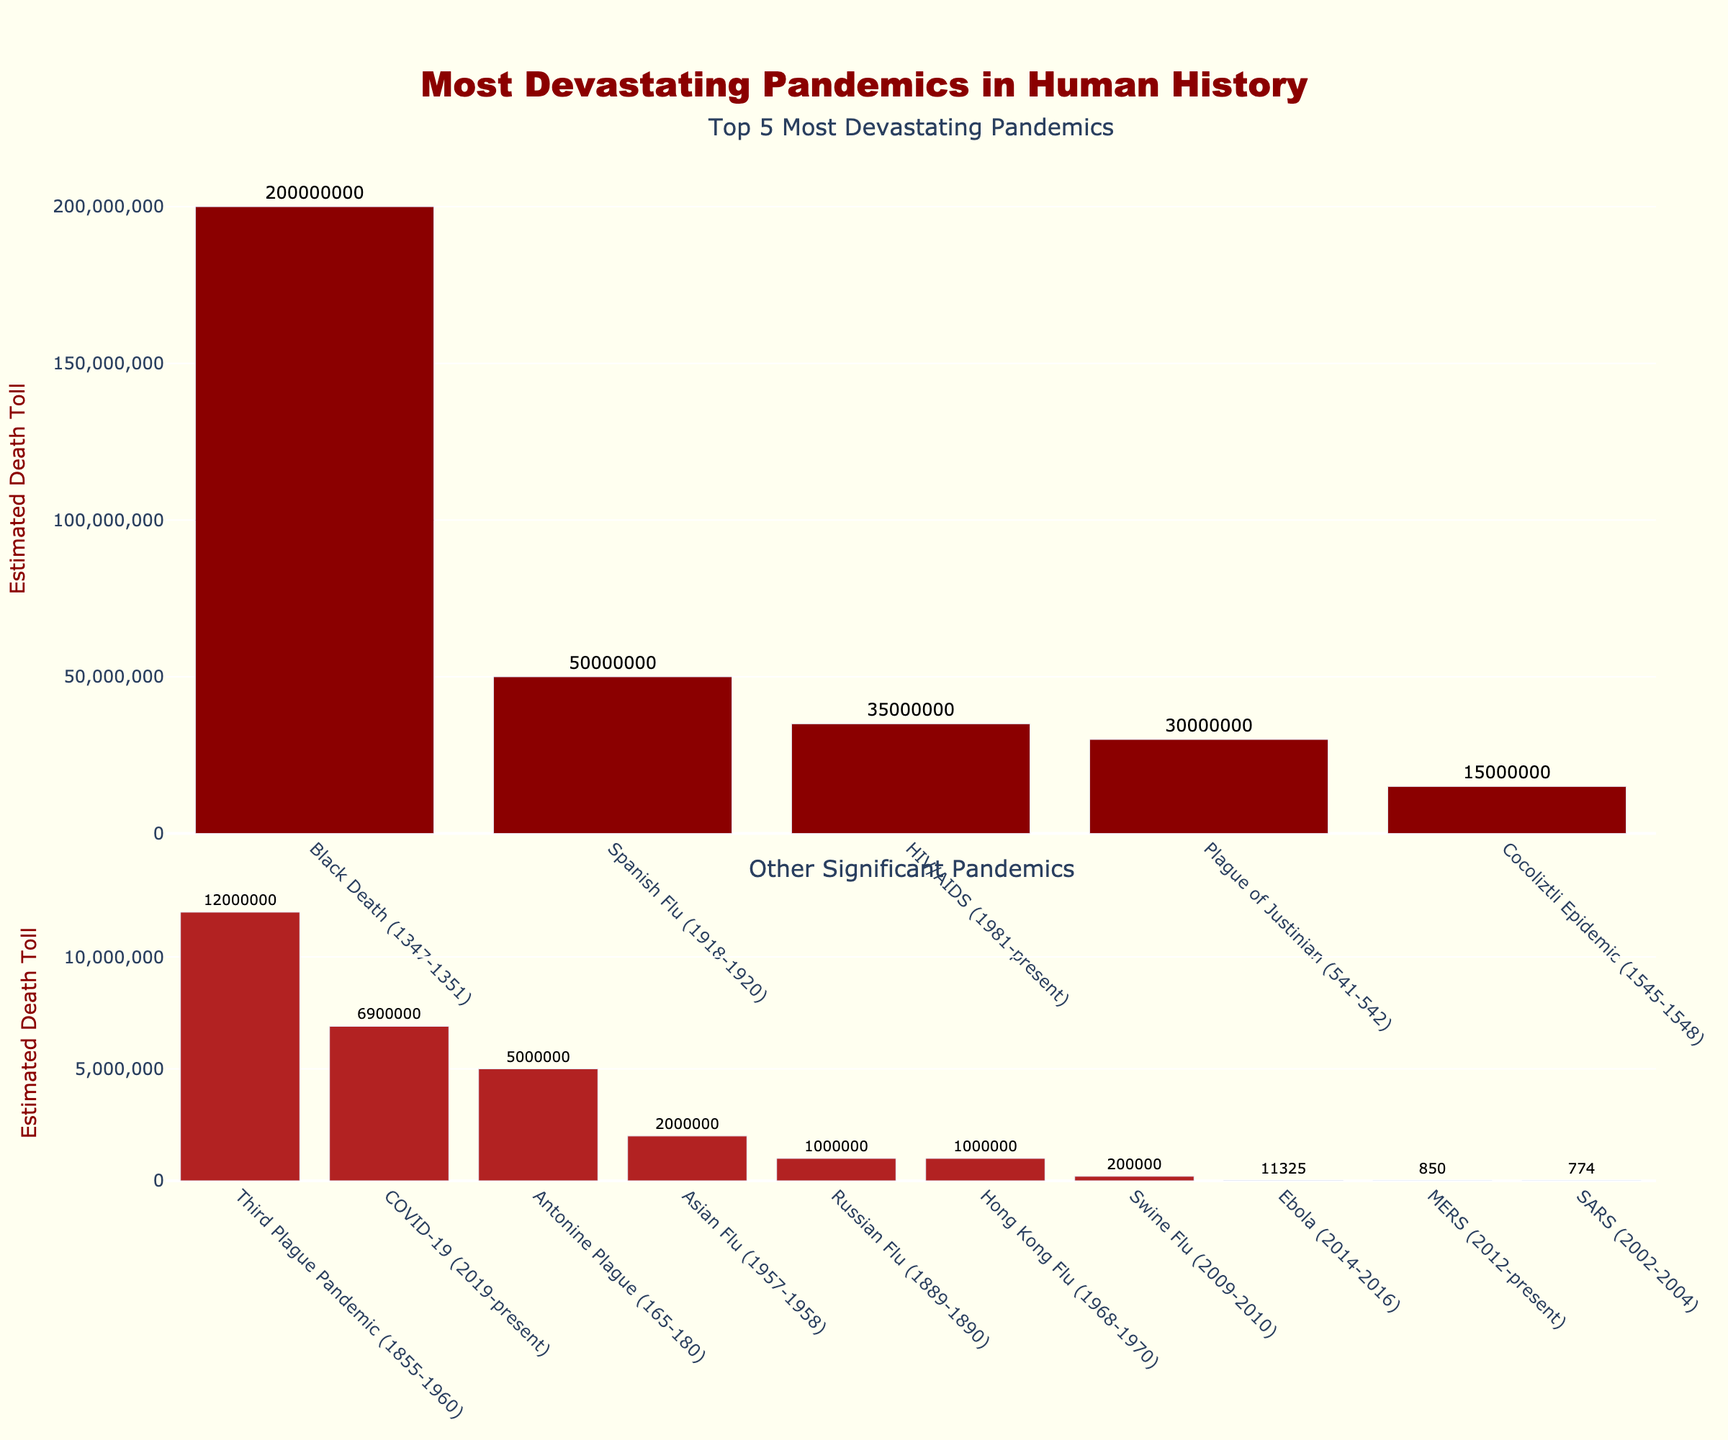Which pandemic had the highest estimated death toll? The tallest bar in the "Top 5 Most Devastating Pandemics" plot represents the Black Death, which indicates it had the highest estimated death toll.
Answer: Black Death How many pandemics had an estimated death toll of fewer than 10 million people? From the "Other Significant Pandemics" plot, count the bars with death tolls listed as fewer than 10 million: COVID-19, Antonine Plague, Russian Flu, Asian Flu, Hong Kong Flu, Swine Flu, SARS, MERS, and Ebola.
Answer: 9 What is the combined estimated death toll of the top 3 pandemics? The estimated death tolls of the top 3 pandemics are Black Death (200,000,000), Spanish Flu (50,000,000), and HIV/AIDS (35,000,000). Their combined total is 200,000,000 + 50,000,000 + 35,000,000 = 285,000,000.
Answer: 285,000,000 Which pandemic in the "Other Significant Pandemics" category had the highest estimated death toll? In the "Other Significant Pandemics" plot, the tallest bar belongs to COVID-19, indicating it had the highest estimated death toll among this group.
Answer: COVID-19 What is the difference in estimated death toll between the Third Plague Pandemic and the Cocoliztli Epidemic? The Third Plague Pandemic has an estimated death toll of 12,000,000, and the Cocoliztli Epidemic has 15,000,000. The difference is 15,000,000 - 12,000,000 = 3,000,000.
Answer: 3,000,000 Which pandemic has a lower estimated death toll: Russian Flu or Asian Flu? Visually compare the heights of the bars for Russian Flu and Asian Flu in the "Other Significant Pandemics" plot. The Russian Flu has a taller bar indicating a higher death toll, so Asian Flu has a lower death toll.
Answer: Asian Flu What is the average estimated death toll of the pandemics listed in the "Other Significant Pandemics" category? The death tolls are COVID-19 (6,900,000), Antonine Plague (5,000,000), Russian Flu (1,000,000), Asian Flu (2,000,000), Hong Kong Flu (1,000,000), Swine Flu (200,000), SARS (774), MERS (850), Ebola (11,325). Their sum is 6,900,000 + 5,000,000 + 1,000,000 + 2,000,000 + 1,000,000 + 200,000 + 774 + 850 + 11,325 = 16,112,949. Divided by 9 yields an average of 16,112,949 / 9 ≈ 1,790,327.
Answer: 1,790,327 Compare the height of the bars for the Spanish Flu and HIV/AIDS; which one had a higher death toll? The bar representing the Spanish Flu is taller than the bar representing HIV/AIDS in the "Top 5 Most Devastating Pandemics" plot, indicating it had a higher death toll.
Answer: Spanish Flu 